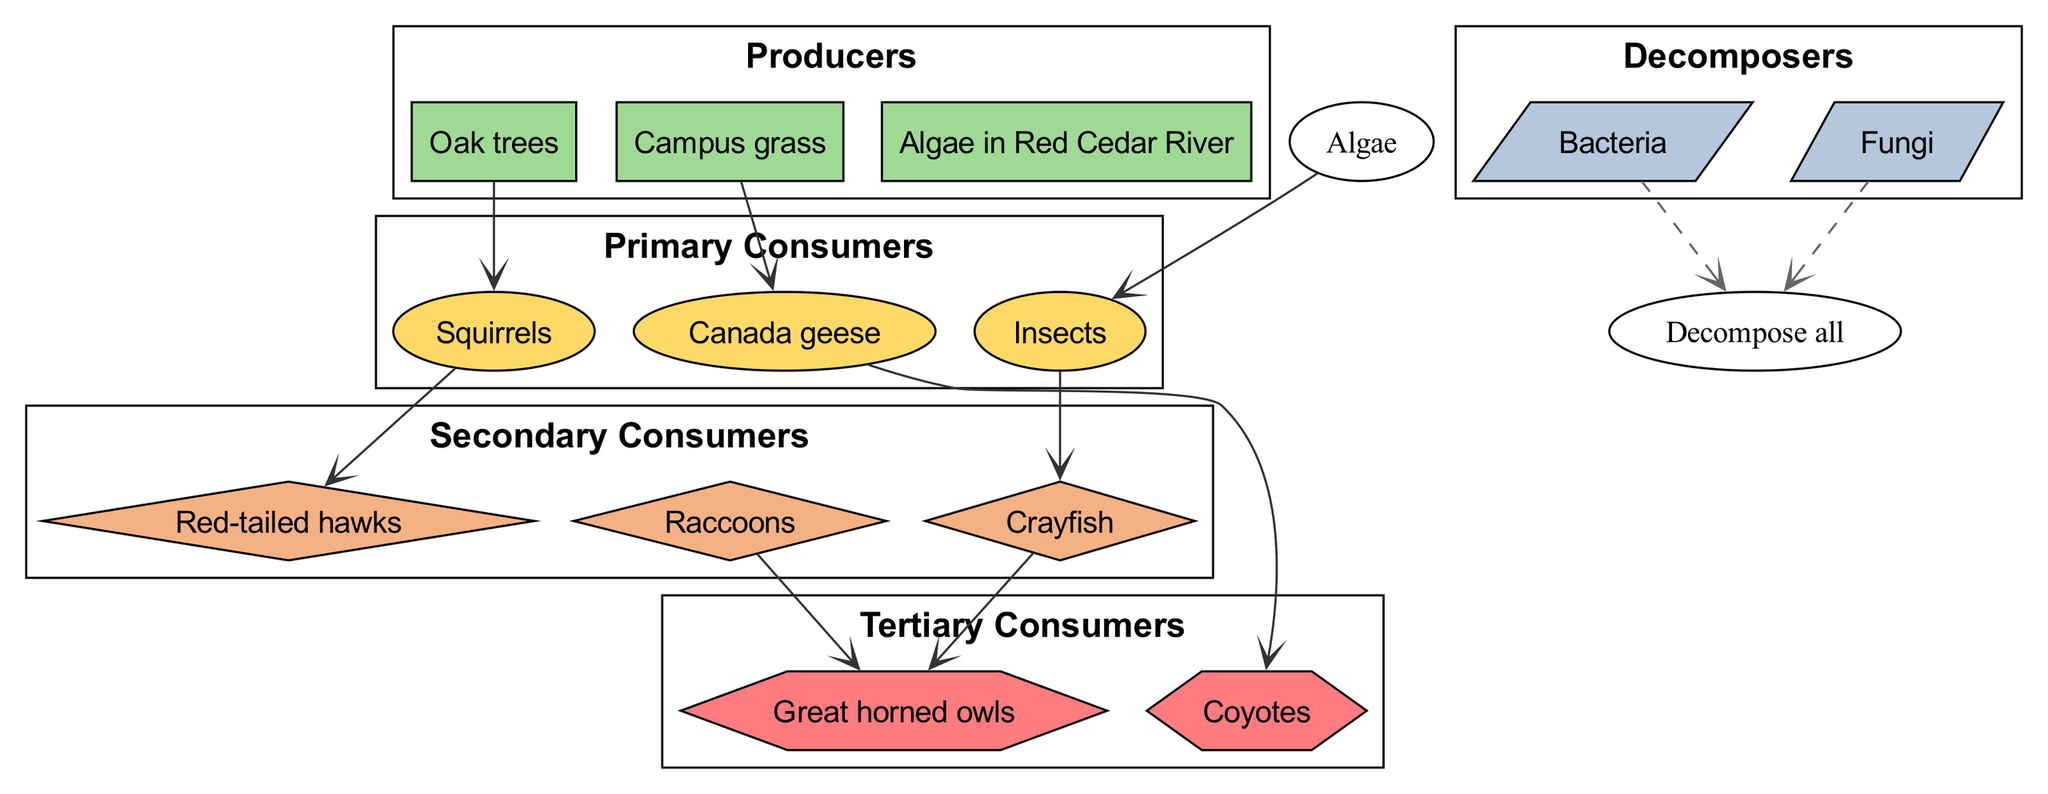What are the producers in the MSU Campus food chain? The producers listed in the diagram are the foundational organisms that create energy through photosynthesis. In this case, the producers are oak trees, campus grass, and algae in the Red Cedar River.
Answer: Oak trees, campus grass, algae in Red Cedar River Which animals are primary consumers in this ecosystem? Primary consumers are organisms that feed directly on producers. According to the diagram, the primary consumers include squirrels, Canada geese, and insects.
Answer: Squirrels, Canada geese, insects How many secondary consumers are depicted in the diagram? Secondary consumers are organisms that eat primary consumers. In this diagram, there are three secondary consumers: red-tailed hawks, raccoons, and crayfish, which totals to three.
Answer: 3 What is the relationship between Canada geese and tertiary consumers? The relationship indicates that Canada geese serve as a food source for tertiary consumers. In the diagram, it shows that Canada geese are preyed upon by coyotes.
Answer: Coyotes Which decomposers are represented in the MSU Campus food chain? Decomposers break down dead organic matter and return nutrients to the ecosystem. The diagram lists bacteria and fungi as the decomposers in this food chain.
Answer: Bacteria, Fungi Do red-tailed hawks have any predators in the ecosystem? To find predators of red-tailed hawks, we need to examine the relationships shown. The diagram shows that raccoons prey on great horned owls, which indicates great horned owls are also considered a top predator with no specific predators listed in this data for red-tailed hawks.
Answer: No specific predators shown Which organism acts as a bridge between primary consumers and secondary consumers? The bridge is formed by organisms that are eaten by secondary consumers but are primary consumers themselves. In this case, squirrels act as a bridge since they are consumed by red-tailed hawks (secondary consumer) while being primary consumers themselves.
Answer: Squirrels How do decomposers contribute to the ecosystem in this food chain? Decomposers like bacteria and fungi break down organic matter, recycling nutrients back into the soil, which supports the growth of producers. This essential role maintains the balance and health of the ecosystem.
Answer: Nutrient recycling 